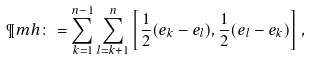Convert formula to latex. <formula><loc_0><loc_0><loc_500><loc_500>\P m h \colon = \sum _ { k = 1 } ^ { n - 1 } \sum _ { l = k + 1 } ^ { n } \left [ \frac { 1 } { 2 } ( e _ { k } - e _ { l } ) , \frac { 1 } { 2 } ( e _ { l } - e _ { k } ) \right ] ,</formula> 